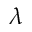<formula> <loc_0><loc_0><loc_500><loc_500>\lambda</formula> 